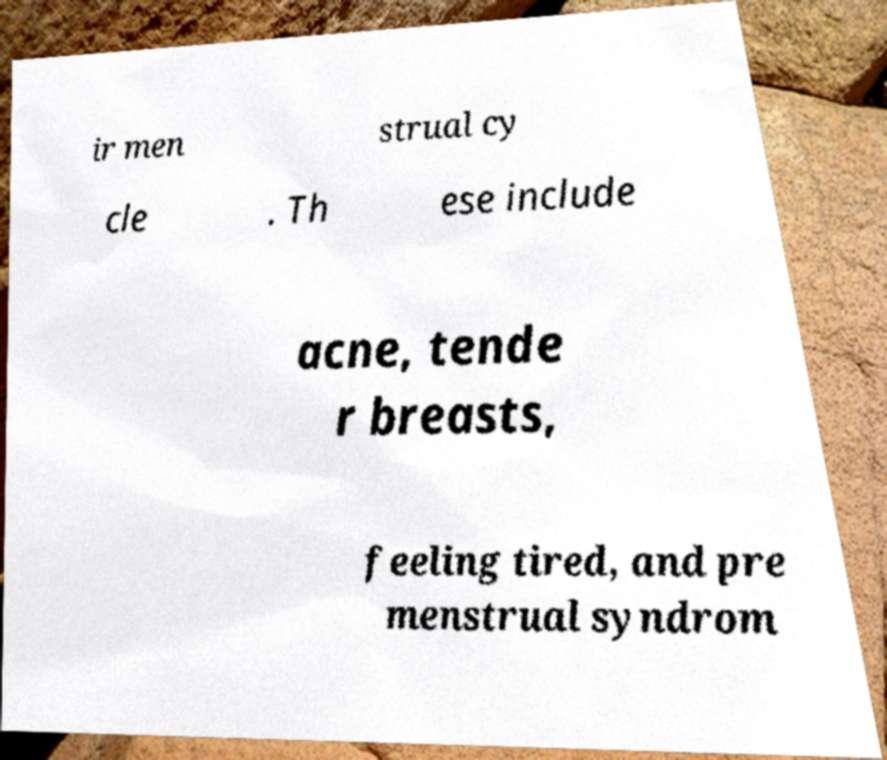I need the written content from this picture converted into text. Can you do that? ir men strual cy cle . Th ese include acne, tende r breasts, feeling tired, and pre menstrual syndrom 